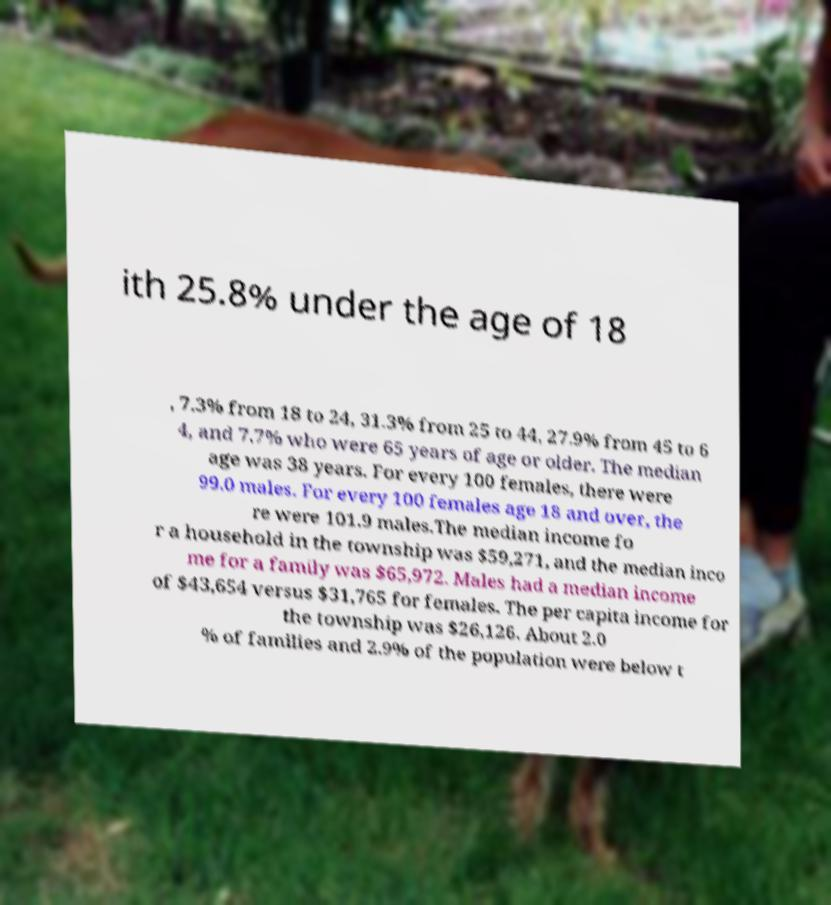Please read and relay the text visible in this image. What does it say? ith 25.8% under the age of 18 , 7.3% from 18 to 24, 31.3% from 25 to 44, 27.9% from 45 to 6 4, and 7.7% who were 65 years of age or older. The median age was 38 years. For every 100 females, there were 99.0 males. For every 100 females age 18 and over, the re were 101.9 males.The median income fo r a household in the township was $59,271, and the median inco me for a family was $65,972. Males had a median income of $43,654 versus $31,765 for females. The per capita income for the township was $26,126. About 2.0 % of families and 2.9% of the population were below t 